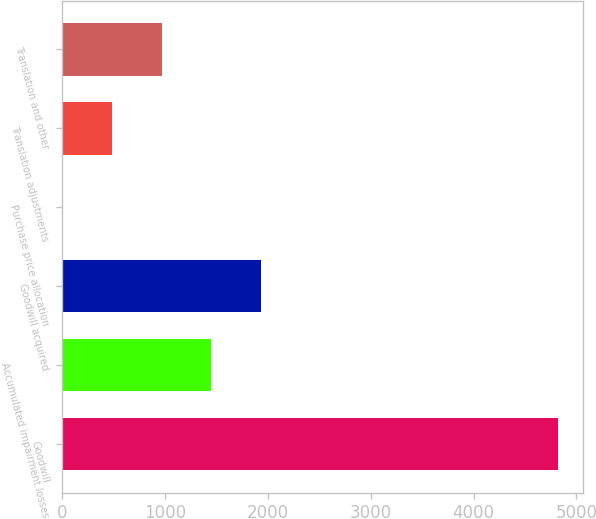Convert chart. <chart><loc_0><loc_0><loc_500><loc_500><bar_chart><fcel>Goodwill<fcel>Accumulated impairment losses<fcel>Goodwill acquired<fcel>Purchase price allocation<fcel>Translation adjustments<fcel>Translation and other<nl><fcel>4820.9<fcel>1451.94<fcel>1933.22<fcel>8.1<fcel>489.38<fcel>970.66<nl></chart> 